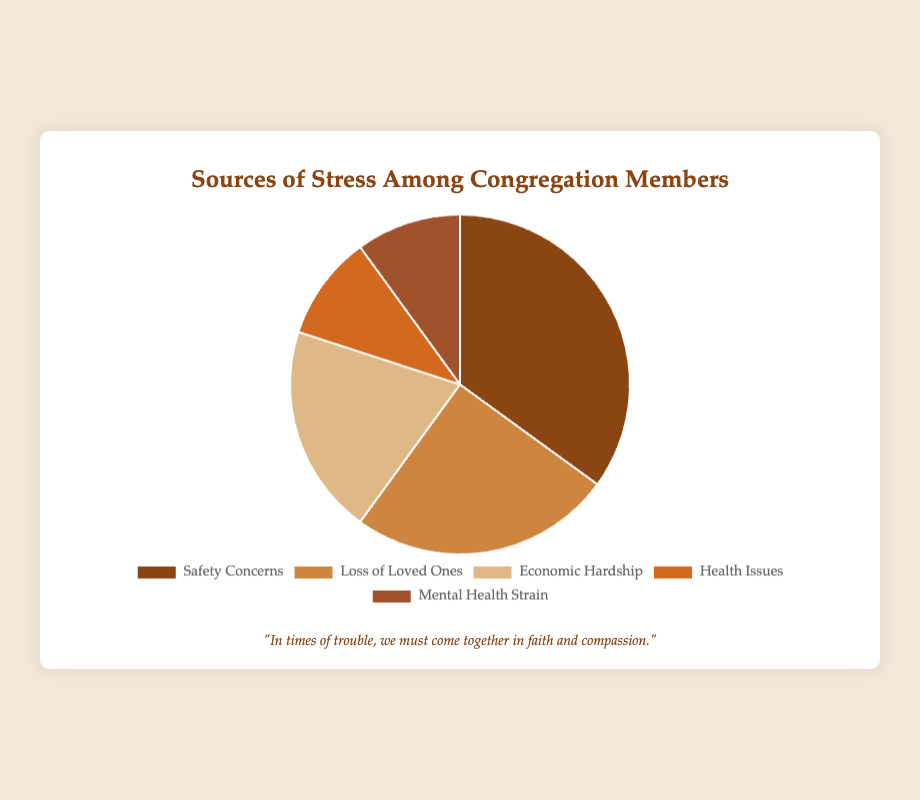What percentage of stress sources are related to health? To find the total percentage of stress sources related to health, we add the percentages of Health Issues and Mental Health Strain. Health Issues are 10% and Mental Health Strain is 10%, so the total is 10 + 10 = 20%
Answer: 20% Which category has the highest percentage of stress? The highest percentage can be identified by looking at the largest slice in the pie chart. Safety Concerns have a percentage of 35%, which is the highest among all categories.
Answer: Safety Concerns How does the percentage of Economic Hardship compare to Loss of Loved Ones? Compared to Loss of Loved Ones at 25%, Economic Hardship is lower. Economic Hardship accounts for 20% of stress, which is 5% less than the 25% of Loss of Loved Ones.
Answer: Economic Hardship is 5% lower What is the difference in percentages between the highest and lowest stress sources? The highest stress source is Safety Concerns at 35%, and the lowest are both Health Issues and Mental Health Strain at 10%. The difference is 35 - 10 = 25%.
Answer: 25% What is the combined percentage for all non-safety related stress sources? To find the combined percentage of non-safety related sources, we add all percentages except Safety Concerns: Loss of Loved Ones (25%) + Economic Hardship (20%) + Health Issues (10%) + Mental Health Strain (10%) = 25 + 20 + 10 + 10 = 65%.
Answer: 65% How much larger is the Safety Concerns category compared to Health Issues? To find how much larger Safety Concerns is compared to Health Issues, we subtract the percentage of Health Issues from Safety Concerns: 35% - 10% = 25%.
Answer: 25% larger What fraction of the stress sources relate to economic and loss combined? To find the fraction of Economic Hardship and Loss of Loved Ones combined, we add their percentages: 20% (Economic Hardship) + 25% (Loss of Loved Ones) = 45%. This fraction is 45/100 or simplified to 9/20.
Answer: 9/20 Which two categories combined are equal to Safety Concerns in percentage? To match the 35% of Safety Concerns, we need to check combinations: Economic Hardship (20%) + Health Issues (10%) + Mental Health Strain (10%) = 40% doesn't work; Loss of Loved Ones (25%) + Economic Hardship (20%) = 45% doesn't work; finally, Health Issues (10%) + Mental Health Strain (10%) + Loss of Loved Ones (25%) = 45% doesn't work. Only Health Issues (10%) + Mental Health Strain (10%) + Economic Hardship (20%) = 40% doesn't work either. Therefore, *no two categories* add up to 35%.
Answer: None What percentage of stresses is neither safety-related nor economic-related? We exclude Safety Concerns (35%) and Economic Hardship (20%) from the total, summarizing Loss of Loved Ones (25%), Health Issues (10%), and Mental Health Strain (10%): 25 + 10 + 10 = 45%.
Answer: 45% 